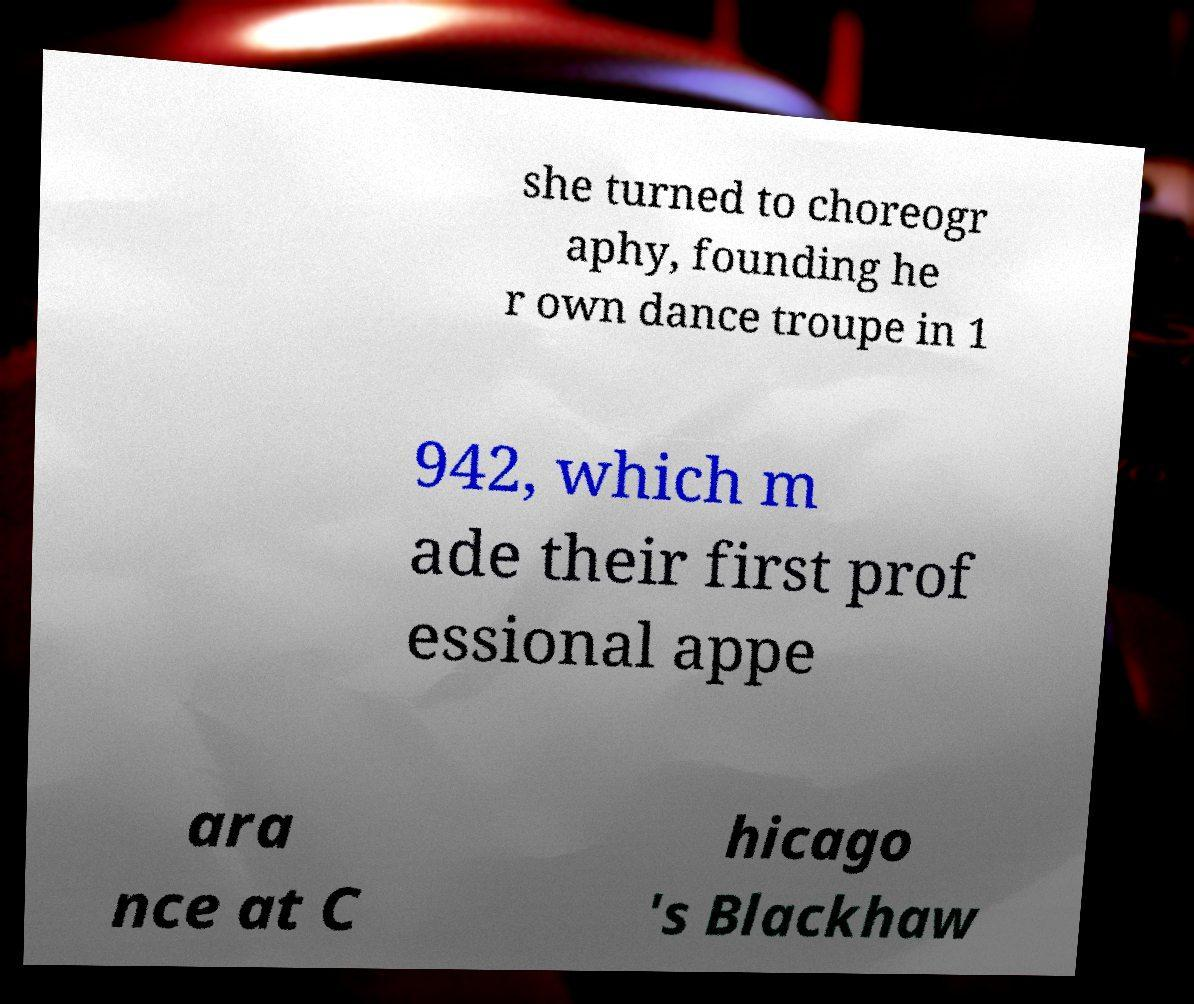Please read and relay the text visible in this image. What does it say? she turned to choreogr aphy, founding he r own dance troupe in 1 942, which m ade their first prof essional appe ara nce at C hicago 's Blackhaw 